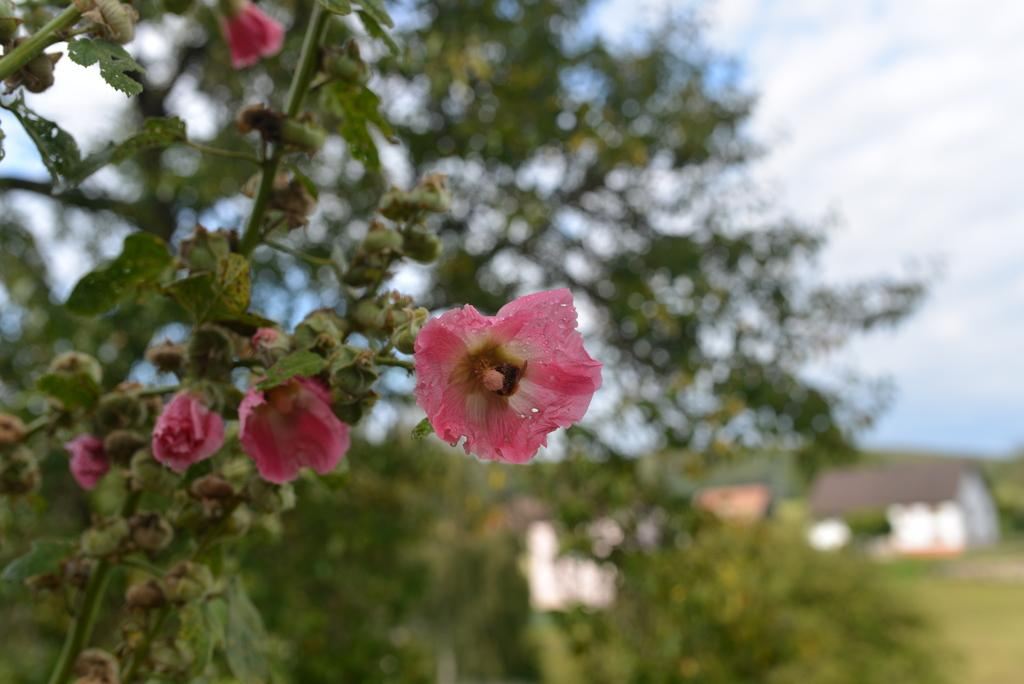What type of flowers can be seen in the image? There are pink flowers in the image. Are there any flowers that are not fully bloomed in the image? Yes, there are flower buds in the image. What other plants are visible in the image? There are trees in the image. How would you describe the background of the image? The background of the image is blurry. What can be seen in the far background of the image? The sky is visible in the background of the image, and clouds are present in the sky. What type of glue is being used to hold the children together in the image? There are no children or glue present in the image; it features pink flowers, flower buds, trees, a blurry background, and the sky with clouds. 